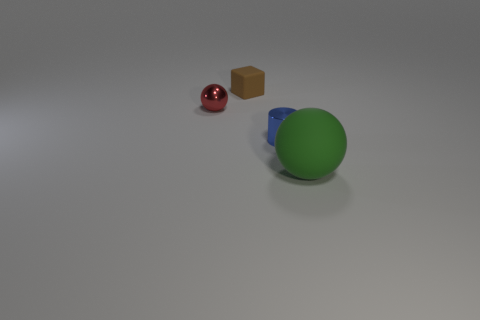Add 1 small green things. How many objects exist? 5 Subtract 1 brown cubes. How many objects are left? 3 Subtract all cylinders. How many objects are left? 3 Subtract all gray cubes. Subtract all blue cylinders. How many cubes are left? 1 Subtract all green cubes. How many gray cylinders are left? 0 Subtract all red things. Subtract all tiny metallic things. How many objects are left? 1 Add 4 small metallic balls. How many small metallic balls are left? 5 Add 4 small blue matte blocks. How many small blue matte blocks exist? 4 Subtract all red balls. How many balls are left? 1 